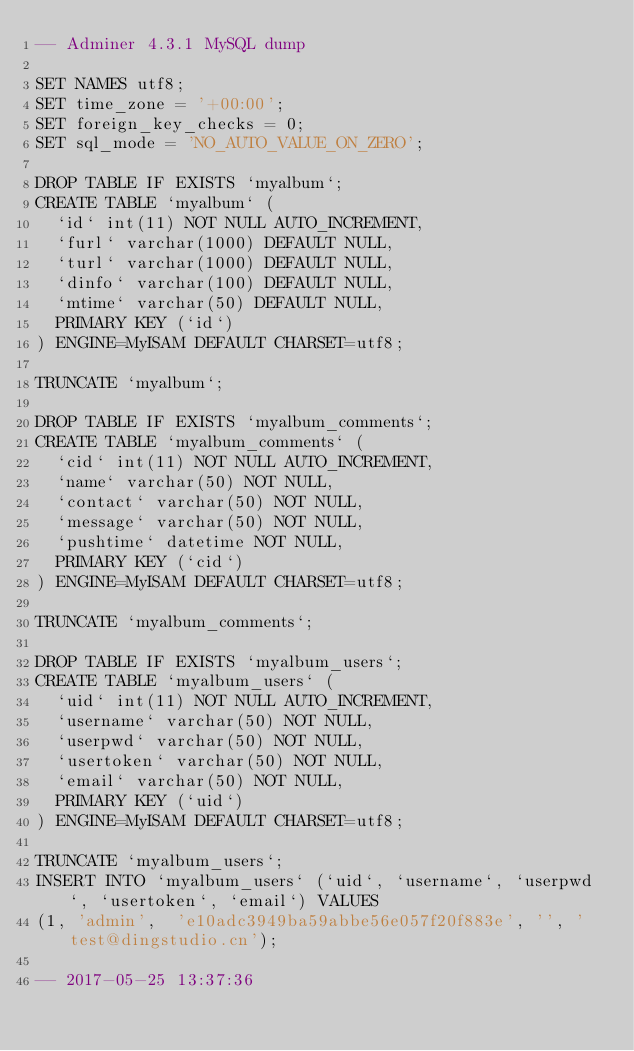Convert code to text. <code><loc_0><loc_0><loc_500><loc_500><_SQL_>-- Adminer 4.3.1 MySQL dump

SET NAMES utf8;
SET time_zone = '+00:00';
SET foreign_key_checks = 0;
SET sql_mode = 'NO_AUTO_VALUE_ON_ZERO';

DROP TABLE IF EXISTS `myalbum`;
CREATE TABLE `myalbum` (
  `id` int(11) NOT NULL AUTO_INCREMENT,
  `furl` varchar(1000) DEFAULT NULL,
  `turl` varchar(1000) DEFAULT NULL,
  `dinfo` varchar(100) DEFAULT NULL,
  `mtime` varchar(50) DEFAULT NULL,
  PRIMARY KEY (`id`)
) ENGINE=MyISAM DEFAULT CHARSET=utf8;

TRUNCATE `myalbum`;

DROP TABLE IF EXISTS `myalbum_comments`;
CREATE TABLE `myalbum_comments` (
  `cid` int(11) NOT NULL AUTO_INCREMENT,
  `name` varchar(50) NOT NULL,
  `contact` varchar(50) NOT NULL,
  `message` varchar(50) NOT NULL,
  `pushtime` datetime NOT NULL,
  PRIMARY KEY (`cid`)
) ENGINE=MyISAM DEFAULT CHARSET=utf8;

TRUNCATE `myalbum_comments`;

DROP TABLE IF EXISTS `myalbum_users`;
CREATE TABLE `myalbum_users` (
  `uid` int(11) NOT NULL AUTO_INCREMENT,
  `username` varchar(50) NOT NULL,
  `userpwd` varchar(50) NOT NULL,
  `usertoken` varchar(50) NOT NULL,
  `email` varchar(50) NOT NULL,
  PRIMARY KEY (`uid`)
) ENGINE=MyISAM DEFAULT CHARSET=utf8;

TRUNCATE `myalbum_users`;
INSERT INTO `myalbum_users` (`uid`, `username`, `userpwd`, `usertoken`, `email`) VALUES
(1,	'admin',	'e10adc3949ba59abbe56e057f20f883e',	'',	'test@dingstudio.cn');

-- 2017-05-25 13:37:36
</code> 